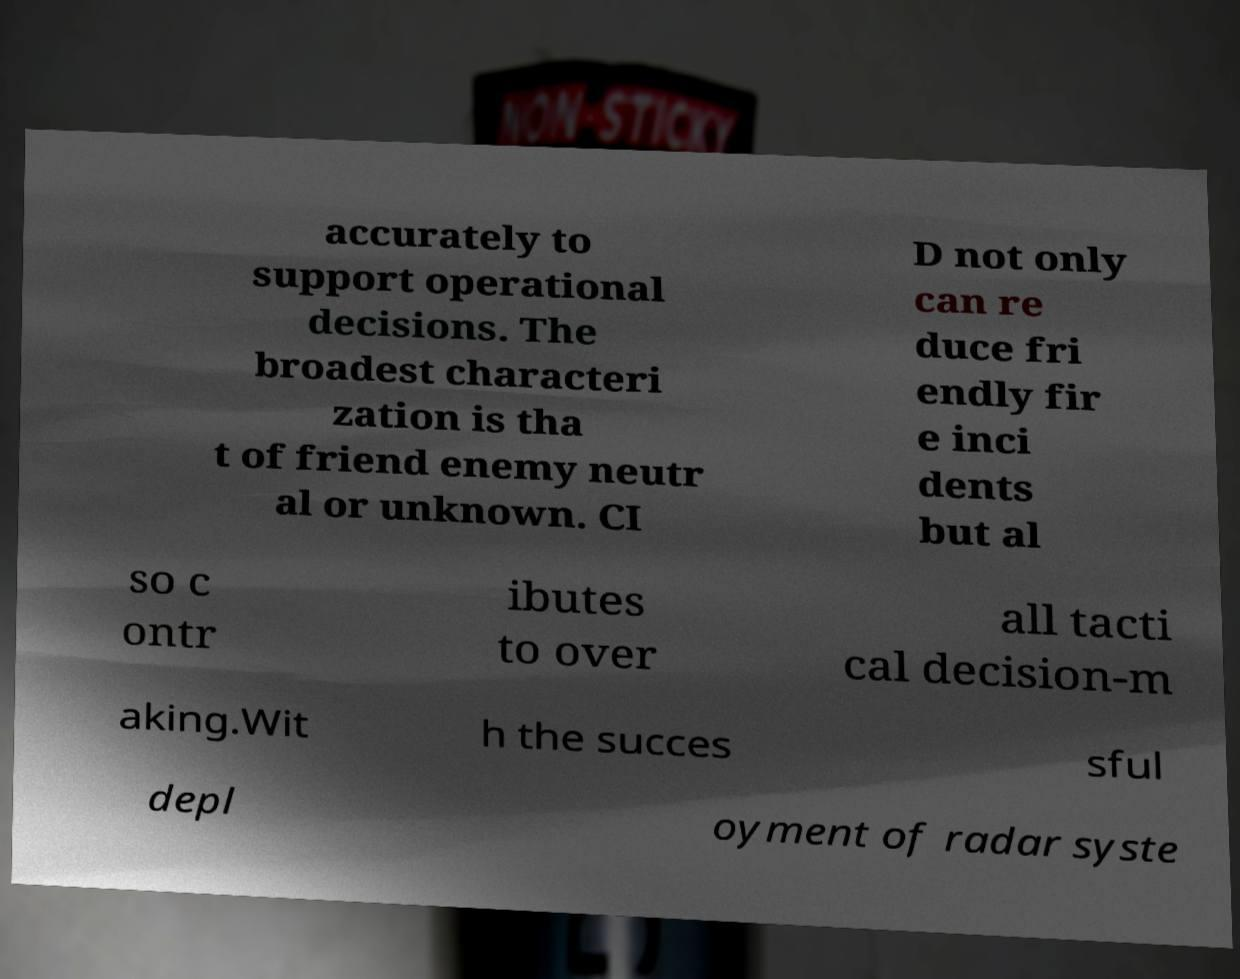Can you read and provide the text displayed in the image?This photo seems to have some interesting text. Can you extract and type it out for me? accurately to support operational decisions. The broadest characteri zation is tha t of friend enemy neutr al or unknown. CI D not only can re duce fri endly fir e inci dents but al so c ontr ibutes to over all tacti cal decision-m aking.Wit h the succes sful depl oyment of radar syste 